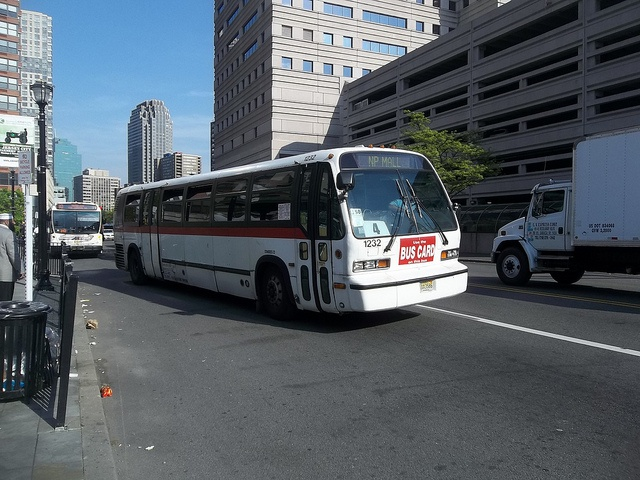Describe the objects in this image and their specific colors. I can see bus in gray, black, white, and blue tones, truck in gray, black, and darkblue tones, bus in gray, black, lightgray, and darkgray tones, people in gray, darkgray, black, and darkblue tones, and people in gray, blue, and teal tones in this image. 